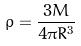<formula> <loc_0><loc_0><loc_500><loc_500>\rho = \frac { 3 M } { 4 \pi R ^ { 3 } }</formula> 